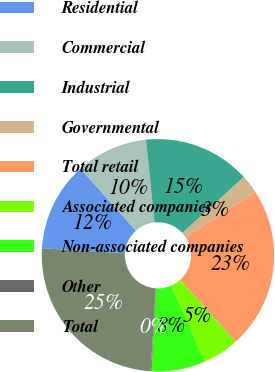<chart> <loc_0><loc_0><loc_500><loc_500><pie_chart><fcel>Residential<fcel>Commercial<fcel>Industrial<fcel>Governmental<fcel>Total retail<fcel>Associated companies<fcel>Non-associated companies<fcel>Other<fcel>Total<nl><fcel>12.42%<fcel>9.96%<fcel>14.88%<fcel>2.58%<fcel>22.51%<fcel>5.04%<fcel>7.5%<fcel>0.12%<fcel>24.97%<nl></chart> 